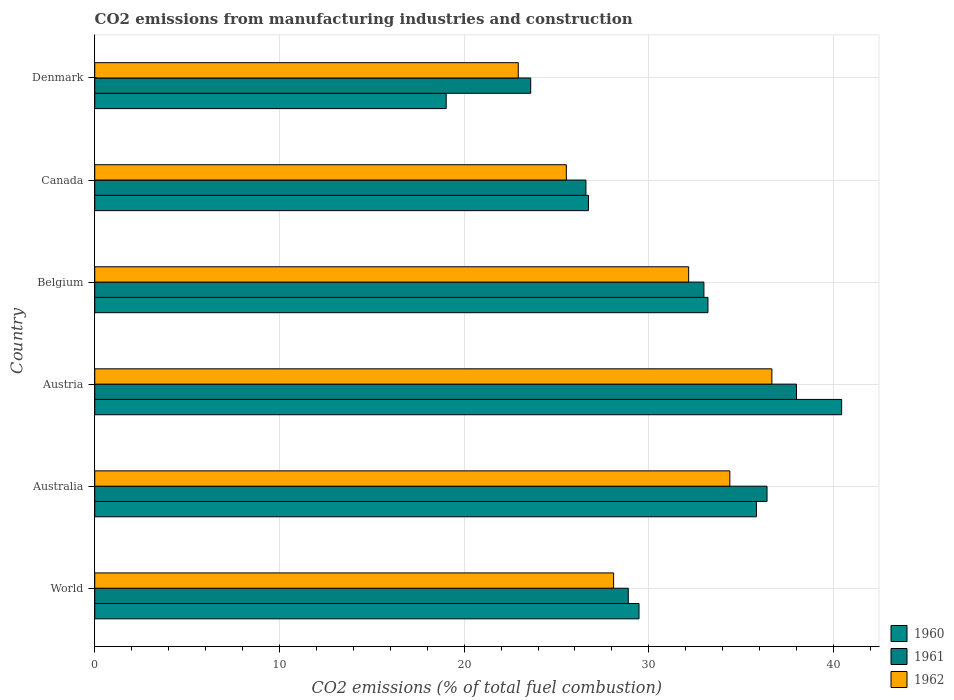How many different coloured bars are there?
Offer a terse response. 3. Are the number of bars per tick equal to the number of legend labels?
Your answer should be very brief. Yes. Are the number of bars on each tick of the Y-axis equal?
Provide a short and direct response. Yes. How many bars are there on the 3rd tick from the top?
Offer a very short reply. 3. How many bars are there on the 2nd tick from the bottom?
Offer a terse response. 3. What is the amount of CO2 emitted in 1961 in Austria?
Your response must be concise. 37.99. Across all countries, what is the maximum amount of CO2 emitted in 1962?
Your answer should be very brief. 36.66. Across all countries, what is the minimum amount of CO2 emitted in 1962?
Offer a terse response. 22.93. In which country was the amount of CO2 emitted in 1960 maximum?
Provide a succinct answer. Austria. What is the total amount of CO2 emitted in 1960 in the graph?
Provide a succinct answer. 184.69. What is the difference between the amount of CO2 emitted in 1962 in Belgium and that in Canada?
Your answer should be compact. 6.62. What is the difference between the amount of CO2 emitted in 1962 in Canada and the amount of CO2 emitted in 1961 in World?
Keep it short and to the point. -3.35. What is the average amount of CO2 emitted in 1962 per country?
Make the answer very short. 29.96. What is the difference between the amount of CO2 emitted in 1961 and amount of CO2 emitted in 1960 in Canada?
Your answer should be very brief. -0.14. In how many countries, is the amount of CO2 emitted in 1962 greater than 4 %?
Make the answer very short. 6. What is the ratio of the amount of CO2 emitted in 1962 in Austria to that in World?
Ensure brevity in your answer.  1.3. Is the difference between the amount of CO2 emitted in 1961 in Australia and Canada greater than the difference between the amount of CO2 emitted in 1960 in Australia and Canada?
Your response must be concise. Yes. What is the difference between the highest and the second highest amount of CO2 emitted in 1961?
Your response must be concise. 1.6. What is the difference between the highest and the lowest amount of CO2 emitted in 1960?
Provide a succinct answer. 21.41. In how many countries, is the amount of CO2 emitted in 1960 greater than the average amount of CO2 emitted in 1960 taken over all countries?
Give a very brief answer. 3. What does the 1st bar from the top in Austria represents?
Your answer should be very brief. 1962. What does the 1st bar from the bottom in Belgium represents?
Your response must be concise. 1960. How many bars are there?
Give a very brief answer. 18. What is the difference between two consecutive major ticks on the X-axis?
Give a very brief answer. 10. Does the graph contain any zero values?
Your answer should be very brief. No. Does the graph contain grids?
Offer a terse response. Yes. Where does the legend appear in the graph?
Give a very brief answer. Bottom right. How are the legend labels stacked?
Offer a terse response. Vertical. What is the title of the graph?
Offer a very short reply. CO2 emissions from manufacturing industries and construction. Does "1987" appear as one of the legend labels in the graph?
Keep it short and to the point. No. What is the label or title of the X-axis?
Keep it short and to the point. CO2 emissions (% of total fuel combustion). What is the label or title of the Y-axis?
Provide a short and direct response. Country. What is the CO2 emissions (% of total fuel combustion) of 1960 in World?
Provide a short and direct response. 29.47. What is the CO2 emissions (% of total fuel combustion) in 1961 in World?
Offer a terse response. 28.89. What is the CO2 emissions (% of total fuel combustion) in 1962 in World?
Provide a short and direct response. 28.09. What is the CO2 emissions (% of total fuel combustion) in 1960 in Australia?
Your response must be concise. 35.83. What is the CO2 emissions (% of total fuel combustion) of 1961 in Australia?
Your answer should be compact. 36.4. What is the CO2 emissions (% of total fuel combustion) of 1962 in Australia?
Provide a succinct answer. 34.39. What is the CO2 emissions (% of total fuel combustion) in 1960 in Austria?
Provide a succinct answer. 40.44. What is the CO2 emissions (% of total fuel combustion) of 1961 in Austria?
Offer a terse response. 37.99. What is the CO2 emissions (% of total fuel combustion) of 1962 in Austria?
Keep it short and to the point. 36.66. What is the CO2 emissions (% of total fuel combustion) in 1960 in Belgium?
Ensure brevity in your answer.  33.2. What is the CO2 emissions (% of total fuel combustion) of 1961 in Belgium?
Give a very brief answer. 32.98. What is the CO2 emissions (% of total fuel combustion) of 1962 in Belgium?
Offer a very short reply. 32.16. What is the CO2 emissions (% of total fuel combustion) in 1960 in Canada?
Your answer should be very brief. 26.73. What is the CO2 emissions (% of total fuel combustion) in 1961 in Canada?
Make the answer very short. 26.59. What is the CO2 emissions (% of total fuel combustion) in 1962 in Canada?
Give a very brief answer. 25.53. What is the CO2 emissions (% of total fuel combustion) of 1960 in Denmark?
Give a very brief answer. 19.03. What is the CO2 emissions (% of total fuel combustion) of 1961 in Denmark?
Give a very brief answer. 23.6. What is the CO2 emissions (% of total fuel combustion) of 1962 in Denmark?
Offer a terse response. 22.93. Across all countries, what is the maximum CO2 emissions (% of total fuel combustion) in 1960?
Make the answer very short. 40.44. Across all countries, what is the maximum CO2 emissions (% of total fuel combustion) in 1961?
Make the answer very short. 37.99. Across all countries, what is the maximum CO2 emissions (% of total fuel combustion) of 1962?
Keep it short and to the point. 36.66. Across all countries, what is the minimum CO2 emissions (% of total fuel combustion) in 1960?
Keep it short and to the point. 19.03. Across all countries, what is the minimum CO2 emissions (% of total fuel combustion) of 1961?
Your answer should be compact. 23.6. Across all countries, what is the minimum CO2 emissions (% of total fuel combustion) in 1962?
Offer a very short reply. 22.93. What is the total CO2 emissions (% of total fuel combustion) in 1960 in the graph?
Offer a very short reply. 184.69. What is the total CO2 emissions (% of total fuel combustion) of 1961 in the graph?
Your answer should be compact. 186.46. What is the total CO2 emissions (% of total fuel combustion) in 1962 in the graph?
Provide a short and direct response. 179.76. What is the difference between the CO2 emissions (% of total fuel combustion) in 1960 in World and that in Australia?
Offer a terse response. -6.36. What is the difference between the CO2 emissions (% of total fuel combustion) of 1961 in World and that in Australia?
Keep it short and to the point. -7.51. What is the difference between the CO2 emissions (% of total fuel combustion) in 1962 in World and that in Australia?
Give a very brief answer. -6.29. What is the difference between the CO2 emissions (% of total fuel combustion) of 1960 in World and that in Austria?
Make the answer very short. -10.97. What is the difference between the CO2 emissions (% of total fuel combustion) of 1961 in World and that in Austria?
Offer a terse response. -9.11. What is the difference between the CO2 emissions (% of total fuel combustion) of 1962 in World and that in Austria?
Give a very brief answer. -8.57. What is the difference between the CO2 emissions (% of total fuel combustion) in 1960 in World and that in Belgium?
Your response must be concise. -3.73. What is the difference between the CO2 emissions (% of total fuel combustion) of 1961 in World and that in Belgium?
Make the answer very short. -4.09. What is the difference between the CO2 emissions (% of total fuel combustion) of 1962 in World and that in Belgium?
Offer a very short reply. -4.06. What is the difference between the CO2 emissions (% of total fuel combustion) in 1960 in World and that in Canada?
Offer a terse response. 2.74. What is the difference between the CO2 emissions (% of total fuel combustion) in 1961 in World and that in Canada?
Provide a succinct answer. 2.29. What is the difference between the CO2 emissions (% of total fuel combustion) of 1962 in World and that in Canada?
Provide a short and direct response. 2.56. What is the difference between the CO2 emissions (% of total fuel combustion) in 1960 in World and that in Denmark?
Your response must be concise. 10.44. What is the difference between the CO2 emissions (% of total fuel combustion) of 1961 in World and that in Denmark?
Give a very brief answer. 5.28. What is the difference between the CO2 emissions (% of total fuel combustion) in 1962 in World and that in Denmark?
Make the answer very short. 5.16. What is the difference between the CO2 emissions (% of total fuel combustion) of 1960 in Australia and that in Austria?
Your answer should be compact. -4.61. What is the difference between the CO2 emissions (% of total fuel combustion) of 1961 in Australia and that in Austria?
Offer a very short reply. -1.6. What is the difference between the CO2 emissions (% of total fuel combustion) in 1962 in Australia and that in Austria?
Provide a short and direct response. -2.28. What is the difference between the CO2 emissions (% of total fuel combustion) in 1960 in Australia and that in Belgium?
Offer a terse response. 2.63. What is the difference between the CO2 emissions (% of total fuel combustion) of 1961 in Australia and that in Belgium?
Provide a succinct answer. 3.42. What is the difference between the CO2 emissions (% of total fuel combustion) of 1962 in Australia and that in Belgium?
Offer a terse response. 2.23. What is the difference between the CO2 emissions (% of total fuel combustion) of 1960 in Australia and that in Canada?
Provide a succinct answer. 9.1. What is the difference between the CO2 emissions (% of total fuel combustion) of 1961 in Australia and that in Canada?
Your answer should be very brief. 9.81. What is the difference between the CO2 emissions (% of total fuel combustion) of 1962 in Australia and that in Canada?
Give a very brief answer. 8.85. What is the difference between the CO2 emissions (% of total fuel combustion) of 1960 in Australia and that in Denmark?
Offer a terse response. 16.8. What is the difference between the CO2 emissions (% of total fuel combustion) in 1961 in Australia and that in Denmark?
Offer a very short reply. 12.8. What is the difference between the CO2 emissions (% of total fuel combustion) in 1962 in Australia and that in Denmark?
Offer a very short reply. 11.46. What is the difference between the CO2 emissions (% of total fuel combustion) in 1960 in Austria and that in Belgium?
Your response must be concise. 7.24. What is the difference between the CO2 emissions (% of total fuel combustion) in 1961 in Austria and that in Belgium?
Your answer should be compact. 5.01. What is the difference between the CO2 emissions (% of total fuel combustion) of 1962 in Austria and that in Belgium?
Ensure brevity in your answer.  4.51. What is the difference between the CO2 emissions (% of total fuel combustion) in 1960 in Austria and that in Canada?
Offer a terse response. 13.71. What is the difference between the CO2 emissions (% of total fuel combustion) in 1961 in Austria and that in Canada?
Offer a very short reply. 11.4. What is the difference between the CO2 emissions (% of total fuel combustion) of 1962 in Austria and that in Canada?
Your answer should be compact. 11.13. What is the difference between the CO2 emissions (% of total fuel combustion) of 1960 in Austria and that in Denmark?
Provide a succinct answer. 21.41. What is the difference between the CO2 emissions (% of total fuel combustion) in 1961 in Austria and that in Denmark?
Provide a short and direct response. 14.39. What is the difference between the CO2 emissions (% of total fuel combustion) in 1962 in Austria and that in Denmark?
Provide a succinct answer. 13.73. What is the difference between the CO2 emissions (% of total fuel combustion) in 1960 in Belgium and that in Canada?
Provide a short and direct response. 6.47. What is the difference between the CO2 emissions (% of total fuel combustion) in 1961 in Belgium and that in Canada?
Ensure brevity in your answer.  6.39. What is the difference between the CO2 emissions (% of total fuel combustion) of 1962 in Belgium and that in Canada?
Offer a terse response. 6.62. What is the difference between the CO2 emissions (% of total fuel combustion) in 1960 in Belgium and that in Denmark?
Offer a very short reply. 14.17. What is the difference between the CO2 emissions (% of total fuel combustion) in 1961 in Belgium and that in Denmark?
Keep it short and to the point. 9.38. What is the difference between the CO2 emissions (% of total fuel combustion) of 1962 in Belgium and that in Denmark?
Your answer should be compact. 9.23. What is the difference between the CO2 emissions (% of total fuel combustion) of 1960 in Canada and that in Denmark?
Your response must be concise. 7.7. What is the difference between the CO2 emissions (% of total fuel combustion) in 1961 in Canada and that in Denmark?
Keep it short and to the point. 2.99. What is the difference between the CO2 emissions (% of total fuel combustion) of 1962 in Canada and that in Denmark?
Provide a succinct answer. 2.6. What is the difference between the CO2 emissions (% of total fuel combustion) of 1960 in World and the CO2 emissions (% of total fuel combustion) of 1961 in Australia?
Ensure brevity in your answer.  -6.93. What is the difference between the CO2 emissions (% of total fuel combustion) in 1960 in World and the CO2 emissions (% of total fuel combustion) in 1962 in Australia?
Provide a succinct answer. -4.92. What is the difference between the CO2 emissions (% of total fuel combustion) in 1961 in World and the CO2 emissions (% of total fuel combustion) in 1962 in Australia?
Offer a very short reply. -5.5. What is the difference between the CO2 emissions (% of total fuel combustion) of 1960 in World and the CO2 emissions (% of total fuel combustion) of 1961 in Austria?
Offer a terse response. -8.53. What is the difference between the CO2 emissions (% of total fuel combustion) in 1960 in World and the CO2 emissions (% of total fuel combustion) in 1962 in Austria?
Provide a succinct answer. -7.19. What is the difference between the CO2 emissions (% of total fuel combustion) of 1961 in World and the CO2 emissions (% of total fuel combustion) of 1962 in Austria?
Your answer should be compact. -7.77. What is the difference between the CO2 emissions (% of total fuel combustion) in 1960 in World and the CO2 emissions (% of total fuel combustion) in 1961 in Belgium?
Provide a short and direct response. -3.51. What is the difference between the CO2 emissions (% of total fuel combustion) of 1960 in World and the CO2 emissions (% of total fuel combustion) of 1962 in Belgium?
Offer a terse response. -2.69. What is the difference between the CO2 emissions (% of total fuel combustion) of 1961 in World and the CO2 emissions (% of total fuel combustion) of 1962 in Belgium?
Offer a terse response. -3.27. What is the difference between the CO2 emissions (% of total fuel combustion) in 1960 in World and the CO2 emissions (% of total fuel combustion) in 1961 in Canada?
Ensure brevity in your answer.  2.87. What is the difference between the CO2 emissions (% of total fuel combustion) in 1960 in World and the CO2 emissions (% of total fuel combustion) in 1962 in Canada?
Make the answer very short. 3.94. What is the difference between the CO2 emissions (% of total fuel combustion) in 1961 in World and the CO2 emissions (% of total fuel combustion) in 1962 in Canada?
Your response must be concise. 3.35. What is the difference between the CO2 emissions (% of total fuel combustion) of 1960 in World and the CO2 emissions (% of total fuel combustion) of 1961 in Denmark?
Your answer should be very brief. 5.86. What is the difference between the CO2 emissions (% of total fuel combustion) of 1960 in World and the CO2 emissions (% of total fuel combustion) of 1962 in Denmark?
Offer a terse response. 6.54. What is the difference between the CO2 emissions (% of total fuel combustion) of 1961 in World and the CO2 emissions (% of total fuel combustion) of 1962 in Denmark?
Offer a terse response. 5.96. What is the difference between the CO2 emissions (% of total fuel combustion) in 1960 in Australia and the CO2 emissions (% of total fuel combustion) in 1961 in Austria?
Offer a very short reply. -2.17. What is the difference between the CO2 emissions (% of total fuel combustion) of 1960 in Australia and the CO2 emissions (% of total fuel combustion) of 1962 in Austria?
Provide a succinct answer. -0.84. What is the difference between the CO2 emissions (% of total fuel combustion) of 1961 in Australia and the CO2 emissions (% of total fuel combustion) of 1962 in Austria?
Your answer should be very brief. -0.26. What is the difference between the CO2 emissions (% of total fuel combustion) of 1960 in Australia and the CO2 emissions (% of total fuel combustion) of 1961 in Belgium?
Keep it short and to the point. 2.84. What is the difference between the CO2 emissions (% of total fuel combustion) in 1960 in Australia and the CO2 emissions (% of total fuel combustion) in 1962 in Belgium?
Make the answer very short. 3.67. What is the difference between the CO2 emissions (% of total fuel combustion) in 1961 in Australia and the CO2 emissions (% of total fuel combustion) in 1962 in Belgium?
Keep it short and to the point. 4.24. What is the difference between the CO2 emissions (% of total fuel combustion) of 1960 in Australia and the CO2 emissions (% of total fuel combustion) of 1961 in Canada?
Give a very brief answer. 9.23. What is the difference between the CO2 emissions (% of total fuel combustion) of 1960 in Australia and the CO2 emissions (% of total fuel combustion) of 1962 in Canada?
Your response must be concise. 10.29. What is the difference between the CO2 emissions (% of total fuel combustion) of 1961 in Australia and the CO2 emissions (% of total fuel combustion) of 1962 in Canada?
Keep it short and to the point. 10.87. What is the difference between the CO2 emissions (% of total fuel combustion) of 1960 in Australia and the CO2 emissions (% of total fuel combustion) of 1961 in Denmark?
Keep it short and to the point. 12.22. What is the difference between the CO2 emissions (% of total fuel combustion) in 1960 in Australia and the CO2 emissions (% of total fuel combustion) in 1962 in Denmark?
Ensure brevity in your answer.  12.9. What is the difference between the CO2 emissions (% of total fuel combustion) in 1961 in Australia and the CO2 emissions (% of total fuel combustion) in 1962 in Denmark?
Your answer should be compact. 13.47. What is the difference between the CO2 emissions (% of total fuel combustion) in 1960 in Austria and the CO2 emissions (% of total fuel combustion) in 1961 in Belgium?
Give a very brief answer. 7.46. What is the difference between the CO2 emissions (% of total fuel combustion) in 1960 in Austria and the CO2 emissions (% of total fuel combustion) in 1962 in Belgium?
Offer a terse response. 8.28. What is the difference between the CO2 emissions (% of total fuel combustion) of 1961 in Austria and the CO2 emissions (% of total fuel combustion) of 1962 in Belgium?
Provide a short and direct response. 5.84. What is the difference between the CO2 emissions (% of total fuel combustion) of 1960 in Austria and the CO2 emissions (% of total fuel combustion) of 1961 in Canada?
Provide a succinct answer. 13.84. What is the difference between the CO2 emissions (% of total fuel combustion) in 1960 in Austria and the CO2 emissions (% of total fuel combustion) in 1962 in Canada?
Your answer should be very brief. 14.91. What is the difference between the CO2 emissions (% of total fuel combustion) in 1961 in Austria and the CO2 emissions (% of total fuel combustion) in 1962 in Canada?
Give a very brief answer. 12.46. What is the difference between the CO2 emissions (% of total fuel combustion) of 1960 in Austria and the CO2 emissions (% of total fuel combustion) of 1961 in Denmark?
Offer a very short reply. 16.84. What is the difference between the CO2 emissions (% of total fuel combustion) in 1960 in Austria and the CO2 emissions (% of total fuel combustion) in 1962 in Denmark?
Your response must be concise. 17.51. What is the difference between the CO2 emissions (% of total fuel combustion) of 1961 in Austria and the CO2 emissions (% of total fuel combustion) of 1962 in Denmark?
Offer a very short reply. 15.06. What is the difference between the CO2 emissions (% of total fuel combustion) in 1960 in Belgium and the CO2 emissions (% of total fuel combustion) in 1961 in Canada?
Make the answer very short. 6.61. What is the difference between the CO2 emissions (% of total fuel combustion) of 1960 in Belgium and the CO2 emissions (% of total fuel combustion) of 1962 in Canada?
Offer a very short reply. 7.67. What is the difference between the CO2 emissions (% of total fuel combustion) in 1961 in Belgium and the CO2 emissions (% of total fuel combustion) in 1962 in Canada?
Provide a succinct answer. 7.45. What is the difference between the CO2 emissions (% of total fuel combustion) of 1960 in Belgium and the CO2 emissions (% of total fuel combustion) of 1961 in Denmark?
Ensure brevity in your answer.  9.6. What is the difference between the CO2 emissions (% of total fuel combustion) in 1960 in Belgium and the CO2 emissions (% of total fuel combustion) in 1962 in Denmark?
Keep it short and to the point. 10.27. What is the difference between the CO2 emissions (% of total fuel combustion) in 1961 in Belgium and the CO2 emissions (% of total fuel combustion) in 1962 in Denmark?
Make the answer very short. 10.05. What is the difference between the CO2 emissions (% of total fuel combustion) in 1960 in Canada and the CO2 emissions (% of total fuel combustion) in 1961 in Denmark?
Offer a terse response. 3.13. What is the difference between the CO2 emissions (% of total fuel combustion) of 1960 in Canada and the CO2 emissions (% of total fuel combustion) of 1962 in Denmark?
Make the answer very short. 3.8. What is the difference between the CO2 emissions (% of total fuel combustion) in 1961 in Canada and the CO2 emissions (% of total fuel combustion) in 1962 in Denmark?
Your answer should be very brief. 3.66. What is the average CO2 emissions (% of total fuel combustion) of 1960 per country?
Your response must be concise. 30.78. What is the average CO2 emissions (% of total fuel combustion) in 1961 per country?
Ensure brevity in your answer.  31.08. What is the average CO2 emissions (% of total fuel combustion) of 1962 per country?
Make the answer very short. 29.96. What is the difference between the CO2 emissions (% of total fuel combustion) in 1960 and CO2 emissions (% of total fuel combustion) in 1961 in World?
Make the answer very short. 0.58. What is the difference between the CO2 emissions (% of total fuel combustion) in 1960 and CO2 emissions (% of total fuel combustion) in 1962 in World?
Your response must be concise. 1.38. What is the difference between the CO2 emissions (% of total fuel combustion) of 1961 and CO2 emissions (% of total fuel combustion) of 1962 in World?
Your answer should be compact. 0.79. What is the difference between the CO2 emissions (% of total fuel combustion) of 1960 and CO2 emissions (% of total fuel combustion) of 1961 in Australia?
Your answer should be compact. -0.57. What is the difference between the CO2 emissions (% of total fuel combustion) of 1960 and CO2 emissions (% of total fuel combustion) of 1962 in Australia?
Offer a terse response. 1.44. What is the difference between the CO2 emissions (% of total fuel combustion) of 1961 and CO2 emissions (% of total fuel combustion) of 1962 in Australia?
Your response must be concise. 2.01. What is the difference between the CO2 emissions (% of total fuel combustion) in 1960 and CO2 emissions (% of total fuel combustion) in 1961 in Austria?
Your answer should be very brief. 2.44. What is the difference between the CO2 emissions (% of total fuel combustion) in 1960 and CO2 emissions (% of total fuel combustion) in 1962 in Austria?
Ensure brevity in your answer.  3.78. What is the difference between the CO2 emissions (% of total fuel combustion) in 1961 and CO2 emissions (% of total fuel combustion) in 1962 in Austria?
Provide a short and direct response. 1.33. What is the difference between the CO2 emissions (% of total fuel combustion) in 1960 and CO2 emissions (% of total fuel combustion) in 1961 in Belgium?
Your response must be concise. 0.22. What is the difference between the CO2 emissions (% of total fuel combustion) in 1960 and CO2 emissions (% of total fuel combustion) in 1962 in Belgium?
Give a very brief answer. 1.04. What is the difference between the CO2 emissions (% of total fuel combustion) of 1961 and CO2 emissions (% of total fuel combustion) of 1962 in Belgium?
Give a very brief answer. 0.83. What is the difference between the CO2 emissions (% of total fuel combustion) of 1960 and CO2 emissions (% of total fuel combustion) of 1961 in Canada?
Keep it short and to the point. 0.14. What is the difference between the CO2 emissions (% of total fuel combustion) in 1960 and CO2 emissions (% of total fuel combustion) in 1962 in Canada?
Ensure brevity in your answer.  1.2. What is the difference between the CO2 emissions (% of total fuel combustion) of 1961 and CO2 emissions (% of total fuel combustion) of 1962 in Canada?
Your answer should be very brief. 1.06. What is the difference between the CO2 emissions (% of total fuel combustion) in 1960 and CO2 emissions (% of total fuel combustion) in 1961 in Denmark?
Give a very brief answer. -4.57. What is the difference between the CO2 emissions (% of total fuel combustion) in 1960 and CO2 emissions (% of total fuel combustion) in 1962 in Denmark?
Provide a succinct answer. -3.9. What is the difference between the CO2 emissions (% of total fuel combustion) of 1961 and CO2 emissions (% of total fuel combustion) of 1962 in Denmark?
Keep it short and to the point. 0.67. What is the ratio of the CO2 emissions (% of total fuel combustion) in 1960 in World to that in Australia?
Ensure brevity in your answer.  0.82. What is the ratio of the CO2 emissions (% of total fuel combustion) in 1961 in World to that in Australia?
Provide a succinct answer. 0.79. What is the ratio of the CO2 emissions (% of total fuel combustion) in 1962 in World to that in Australia?
Provide a short and direct response. 0.82. What is the ratio of the CO2 emissions (% of total fuel combustion) in 1960 in World to that in Austria?
Offer a very short reply. 0.73. What is the ratio of the CO2 emissions (% of total fuel combustion) in 1961 in World to that in Austria?
Make the answer very short. 0.76. What is the ratio of the CO2 emissions (% of total fuel combustion) of 1962 in World to that in Austria?
Give a very brief answer. 0.77. What is the ratio of the CO2 emissions (% of total fuel combustion) in 1960 in World to that in Belgium?
Provide a succinct answer. 0.89. What is the ratio of the CO2 emissions (% of total fuel combustion) of 1961 in World to that in Belgium?
Provide a succinct answer. 0.88. What is the ratio of the CO2 emissions (% of total fuel combustion) of 1962 in World to that in Belgium?
Give a very brief answer. 0.87. What is the ratio of the CO2 emissions (% of total fuel combustion) of 1960 in World to that in Canada?
Provide a short and direct response. 1.1. What is the ratio of the CO2 emissions (% of total fuel combustion) in 1961 in World to that in Canada?
Keep it short and to the point. 1.09. What is the ratio of the CO2 emissions (% of total fuel combustion) in 1962 in World to that in Canada?
Give a very brief answer. 1.1. What is the ratio of the CO2 emissions (% of total fuel combustion) of 1960 in World to that in Denmark?
Offer a terse response. 1.55. What is the ratio of the CO2 emissions (% of total fuel combustion) of 1961 in World to that in Denmark?
Keep it short and to the point. 1.22. What is the ratio of the CO2 emissions (% of total fuel combustion) in 1962 in World to that in Denmark?
Give a very brief answer. 1.23. What is the ratio of the CO2 emissions (% of total fuel combustion) of 1960 in Australia to that in Austria?
Provide a short and direct response. 0.89. What is the ratio of the CO2 emissions (% of total fuel combustion) of 1961 in Australia to that in Austria?
Make the answer very short. 0.96. What is the ratio of the CO2 emissions (% of total fuel combustion) of 1962 in Australia to that in Austria?
Provide a short and direct response. 0.94. What is the ratio of the CO2 emissions (% of total fuel combustion) of 1960 in Australia to that in Belgium?
Your answer should be compact. 1.08. What is the ratio of the CO2 emissions (% of total fuel combustion) of 1961 in Australia to that in Belgium?
Provide a short and direct response. 1.1. What is the ratio of the CO2 emissions (% of total fuel combustion) in 1962 in Australia to that in Belgium?
Keep it short and to the point. 1.07. What is the ratio of the CO2 emissions (% of total fuel combustion) of 1960 in Australia to that in Canada?
Offer a very short reply. 1.34. What is the ratio of the CO2 emissions (% of total fuel combustion) of 1961 in Australia to that in Canada?
Offer a terse response. 1.37. What is the ratio of the CO2 emissions (% of total fuel combustion) of 1962 in Australia to that in Canada?
Your answer should be compact. 1.35. What is the ratio of the CO2 emissions (% of total fuel combustion) of 1960 in Australia to that in Denmark?
Your response must be concise. 1.88. What is the ratio of the CO2 emissions (% of total fuel combustion) in 1961 in Australia to that in Denmark?
Offer a very short reply. 1.54. What is the ratio of the CO2 emissions (% of total fuel combustion) of 1962 in Australia to that in Denmark?
Ensure brevity in your answer.  1.5. What is the ratio of the CO2 emissions (% of total fuel combustion) in 1960 in Austria to that in Belgium?
Provide a succinct answer. 1.22. What is the ratio of the CO2 emissions (% of total fuel combustion) of 1961 in Austria to that in Belgium?
Offer a very short reply. 1.15. What is the ratio of the CO2 emissions (% of total fuel combustion) of 1962 in Austria to that in Belgium?
Your answer should be very brief. 1.14. What is the ratio of the CO2 emissions (% of total fuel combustion) of 1960 in Austria to that in Canada?
Keep it short and to the point. 1.51. What is the ratio of the CO2 emissions (% of total fuel combustion) of 1961 in Austria to that in Canada?
Provide a short and direct response. 1.43. What is the ratio of the CO2 emissions (% of total fuel combustion) in 1962 in Austria to that in Canada?
Give a very brief answer. 1.44. What is the ratio of the CO2 emissions (% of total fuel combustion) in 1960 in Austria to that in Denmark?
Offer a terse response. 2.13. What is the ratio of the CO2 emissions (% of total fuel combustion) in 1961 in Austria to that in Denmark?
Keep it short and to the point. 1.61. What is the ratio of the CO2 emissions (% of total fuel combustion) of 1962 in Austria to that in Denmark?
Your response must be concise. 1.6. What is the ratio of the CO2 emissions (% of total fuel combustion) in 1960 in Belgium to that in Canada?
Give a very brief answer. 1.24. What is the ratio of the CO2 emissions (% of total fuel combustion) in 1961 in Belgium to that in Canada?
Make the answer very short. 1.24. What is the ratio of the CO2 emissions (% of total fuel combustion) in 1962 in Belgium to that in Canada?
Give a very brief answer. 1.26. What is the ratio of the CO2 emissions (% of total fuel combustion) of 1960 in Belgium to that in Denmark?
Your answer should be very brief. 1.74. What is the ratio of the CO2 emissions (% of total fuel combustion) of 1961 in Belgium to that in Denmark?
Your response must be concise. 1.4. What is the ratio of the CO2 emissions (% of total fuel combustion) of 1962 in Belgium to that in Denmark?
Offer a very short reply. 1.4. What is the ratio of the CO2 emissions (% of total fuel combustion) in 1960 in Canada to that in Denmark?
Keep it short and to the point. 1.4. What is the ratio of the CO2 emissions (% of total fuel combustion) of 1961 in Canada to that in Denmark?
Make the answer very short. 1.13. What is the ratio of the CO2 emissions (% of total fuel combustion) in 1962 in Canada to that in Denmark?
Your response must be concise. 1.11. What is the difference between the highest and the second highest CO2 emissions (% of total fuel combustion) in 1960?
Make the answer very short. 4.61. What is the difference between the highest and the second highest CO2 emissions (% of total fuel combustion) of 1961?
Provide a short and direct response. 1.6. What is the difference between the highest and the second highest CO2 emissions (% of total fuel combustion) of 1962?
Offer a terse response. 2.28. What is the difference between the highest and the lowest CO2 emissions (% of total fuel combustion) in 1960?
Provide a short and direct response. 21.41. What is the difference between the highest and the lowest CO2 emissions (% of total fuel combustion) in 1961?
Your answer should be compact. 14.39. What is the difference between the highest and the lowest CO2 emissions (% of total fuel combustion) in 1962?
Ensure brevity in your answer.  13.73. 